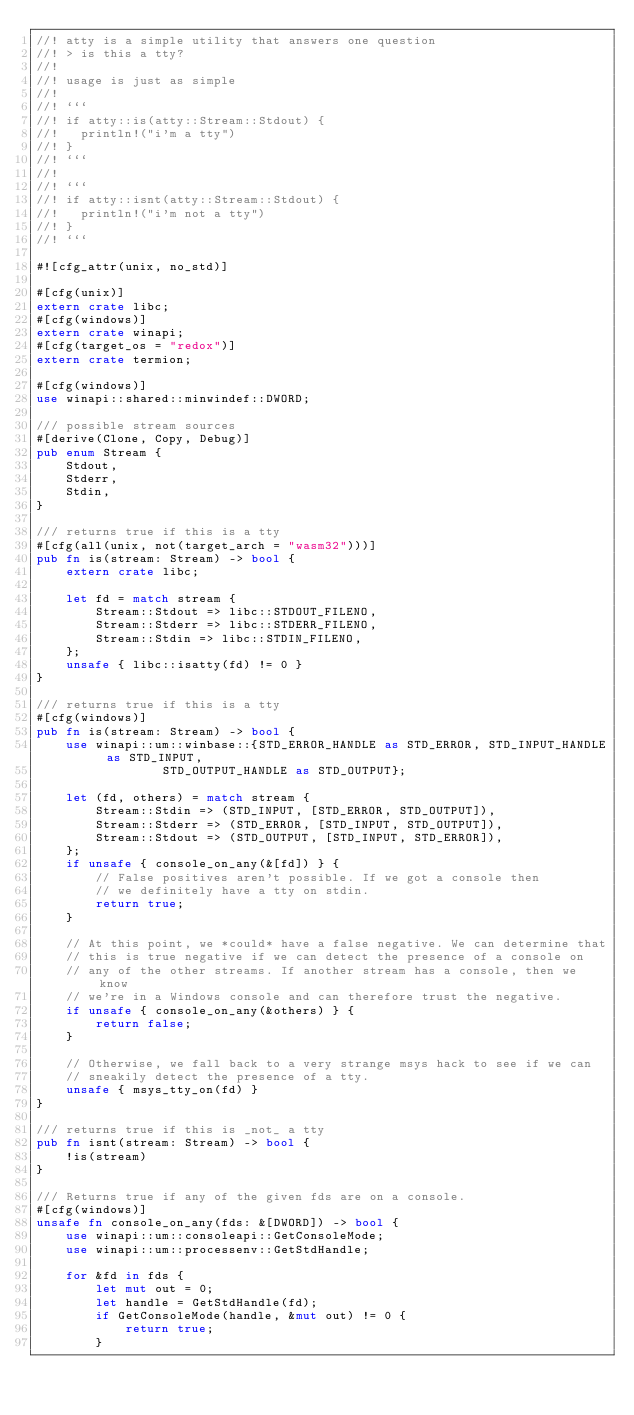Convert code to text. <code><loc_0><loc_0><loc_500><loc_500><_Rust_>//! atty is a simple utility that answers one question
//! > is this a tty?
//!
//! usage is just as simple
//!
//! ```
//! if atty::is(atty::Stream::Stdout) {
//!   println!("i'm a tty")
//! }
//! ```
//!
//! ```
//! if atty::isnt(atty::Stream::Stdout) {
//!   println!("i'm not a tty")
//! }
//! ```

#![cfg_attr(unix, no_std)]

#[cfg(unix)]
extern crate libc;
#[cfg(windows)]
extern crate winapi;
#[cfg(target_os = "redox")]
extern crate termion;

#[cfg(windows)]
use winapi::shared::minwindef::DWORD;

/// possible stream sources
#[derive(Clone, Copy, Debug)]
pub enum Stream {
    Stdout,
    Stderr,
    Stdin,
}

/// returns true if this is a tty
#[cfg(all(unix, not(target_arch = "wasm32")))]
pub fn is(stream: Stream) -> bool {
    extern crate libc;

    let fd = match stream {
        Stream::Stdout => libc::STDOUT_FILENO,
        Stream::Stderr => libc::STDERR_FILENO,
        Stream::Stdin => libc::STDIN_FILENO,
    };
    unsafe { libc::isatty(fd) != 0 }
}

/// returns true if this is a tty
#[cfg(windows)]
pub fn is(stream: Stream) -> bool {
    use winapi::um::winbase::{STD_ERROR_HANDLE as STD_ERROR, STD_INPUT_HANDLE as STD_INPUT,
                 STD_OUTPUT_HANDLE as STD_OUTPUT};

    let (fd, others) = match stream {
        Stream::Stdin => (STD_INPUT, [STD_ERROR, STD_OUTPUT]),
        Stream::Stderr => (STD_ERROR, [STD_INPUT, STD_OUTPUT]),
        Stream::Stdout => (STD_OUTPUT, [STD_INPUT, STD_ERROR]),
    };
    if unsafe { console_on_any(&[fd]) } {
        // False positives aren't possible. If we got a console then
        // we definitely have a tty on stdin.
        return true;
    }

    // At this point, we *could* have a false negative. We can determine that
    // this is true negative if we can detect the presence of a console on
    // any of the other streams. If another stream has a console, then we know
    // we're in a Windows console and can therefore trust the negative.
    if unsafe { console_on_any(&others) } {
        return false;
    }

    // Otherwise, we fall back to a very strange msys hack to see if we can
    // sneakily detect the presence of a tty.
    unsafe { msys_tty_on(fd) }
}

/// returns true if this is _not_ a tty
pub fn isnt(stream: Stream) -> bool {
    !is(stream)
}

/// Returns true if any of the given fds are on a console.
#[cfg(windows)]
unsafe fn console_on_any(fds: &[DWORD]) -> bool {
    use winapi::um::consoleapi::GetConsoleMode;
    use winapi::um::processenv::GetStdHandle;

    for &fd in fds {
        let mut out = 0;
        let handle = GetStdHandle(fd);
        if GetConsoleMode(handle, &mut out) != 0 {
            return true;
        }</code> 